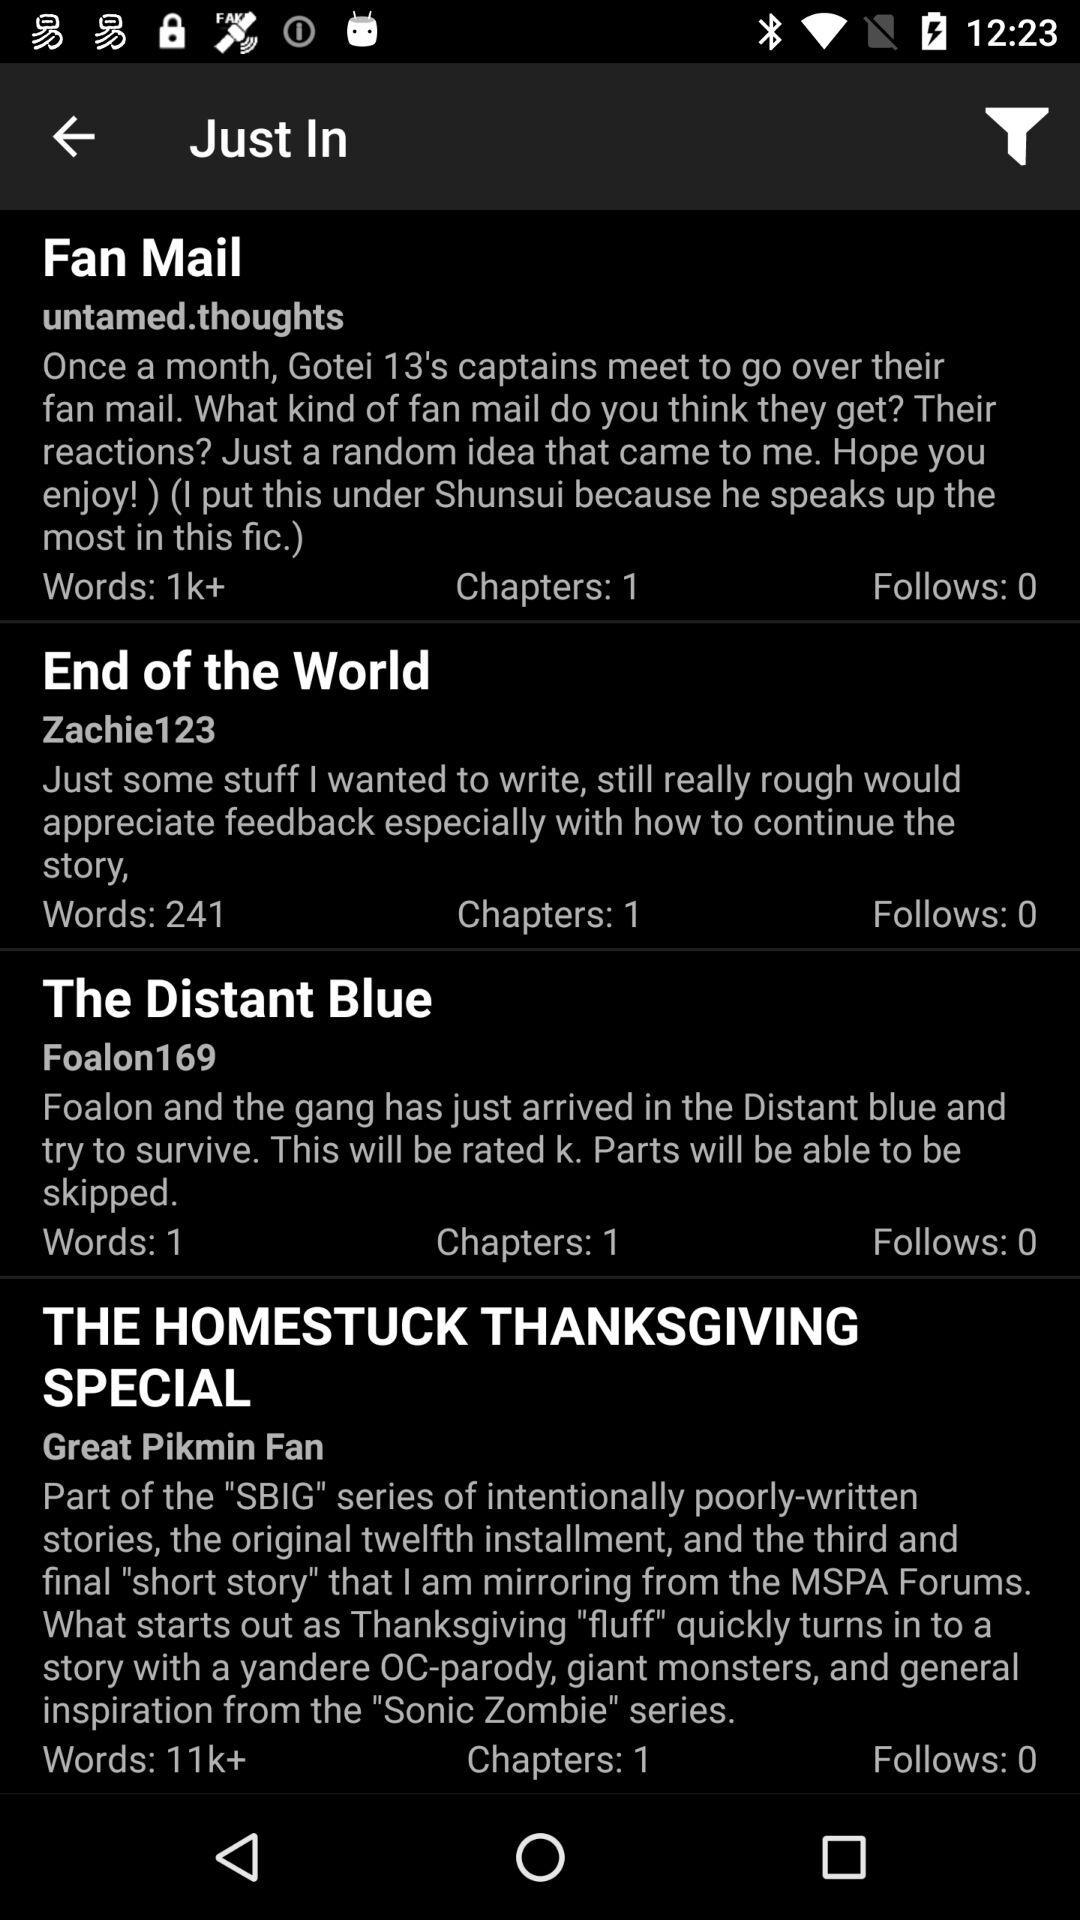How many chapters are there in "Fan Mail"? There is 1 chapter in "Fan Mail". 